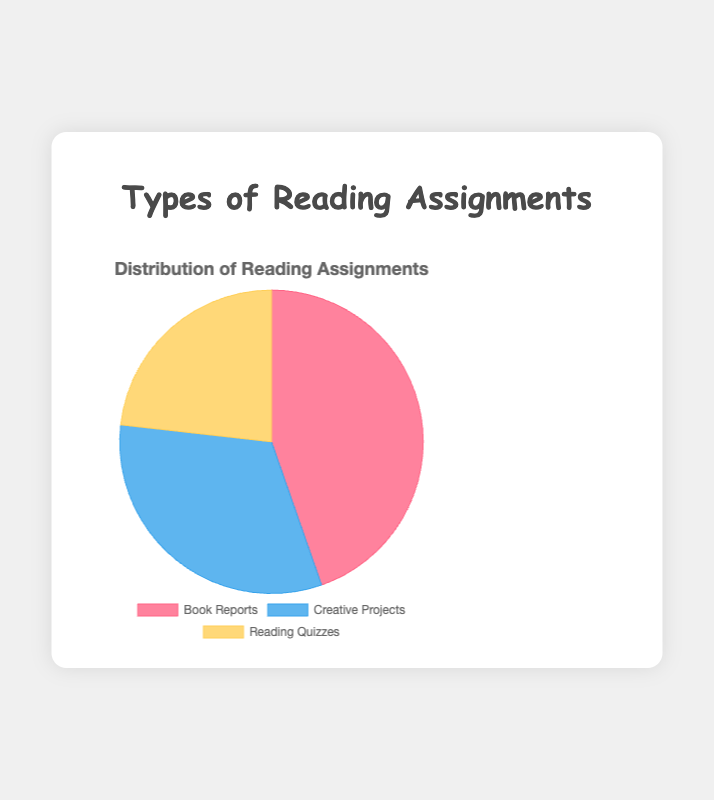Which type of reading assignment has the largest portion in the pie chart? By visual inspection, the largest portion of the pie chart represents the type with the highest percentage of data points. The segment representing "Book Reports" takes up the most space.
Answer: Book Reports Which reading assignment type has the smallest portion in the pie chart? Simply look for the smallest segment in the pie chart, which represents the smallest percentage of data points. "Reading Quizzes" occupies the smallest area.
Answer: Reading Quizzes Which two segments are closest in size? By comparing the segments directly, "Creative Projects" and "Reading Quizzes" are more similar in size to each other than to "Book Reports".
Answer: Creative Projects and Reading Quizzes What is the combined percentage of Book Reports and Creative Projects? Sum the portions represented by Book Reports (125) and Creative Projects (90). The sum is 125 + 90 = 215. To find the percentage, calculate (215 / (125 + 90 + 65)) * 100 = 63.24%.
Answer: 63.24% What is the ratio of Book Reports to Reading Quizzes? Divide the portion for Book Reports (125) by the portion for Reading Quizzes (65). The ratio is 125/65 = 1.92.
Answer: 1.92 What color is used to represent Creative Projects in the pie chart? Refer to the chart legend, where colors are matched with data labels. Creative Projects are represented by blue.
Answer: Blue Which segment would change the most visually if its portion was increased by 10%? Determine the effect of a 10% increase on each segment. A 10% increase of Reading Quizzes (65) to 65 + 65 * 0.10 = 71.5 would create a significant visual change compared to increases in already larger segments like Book Reports (125).
Answer: Reading Quizzes If the portion of Reading Quizzes increased by 20 points, would it become larger than Creative Projects? Add 20 to the portion for Reading Quizzes (65), getting 85. Compare with Creative Projects (90). 85 < 90, so Reading Quizzes will still be smaller.
Answer: No What is the difference in percentage between the largest and smallest assignment types? Calculate the differences between the largest (Book Reports, 125) and smallest (Reading Quizzes, 65) values. The difference is (125 - 65) = 60. To find the percentage, (60 / (125 + 90 + 65)) * 100 = 17.65%.
Answer: 17.65% What is the percentage difference between Book Reports and Creative Projects? Calculate  the difference, which is (125 - 90) = 35. Determine the overall percentage (35 / (125 + 90 + 65)) * 100 = 10.29%.
Answer: 10.29% 